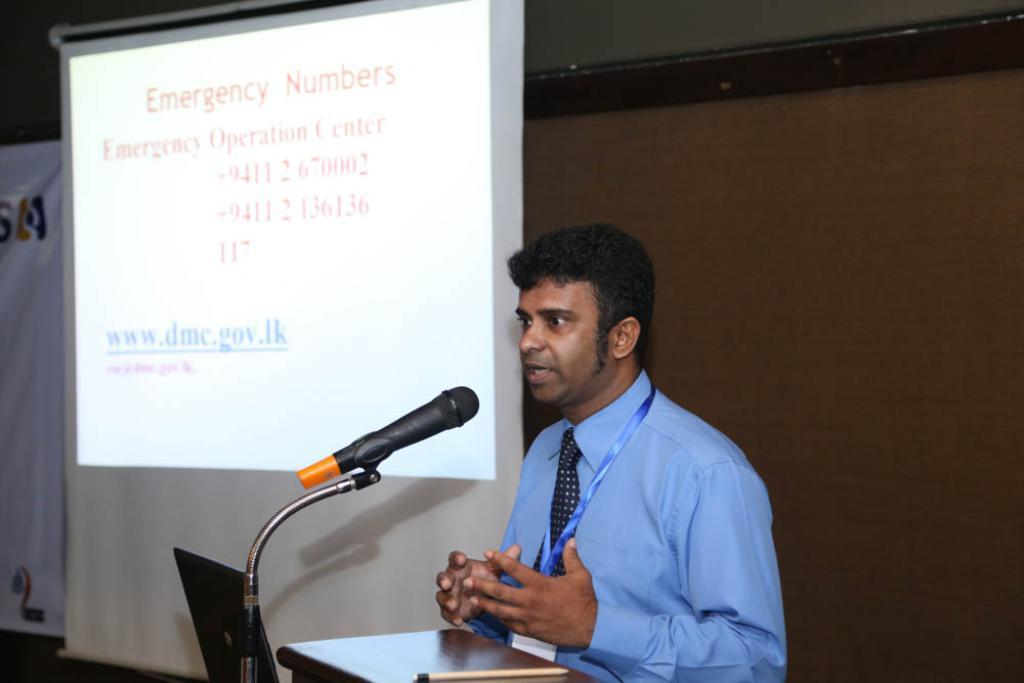Can you describe this image briefly? In the center of the image we can see a man is standing and talking, in-front of him we can see a table. On the table we can see a pen. At the bottom of the image we can see a laptop and mic with stand. In the background of the image we can see the wall, screen, banner. At the top of the image we can see the roof. 